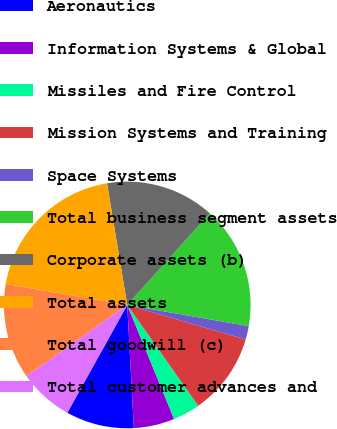<chart> <loc_0><loc_0><loc_500><loc_500><pie_chart><fcel>Aeronautics<fcel>Information Systems & Global<fcel>Missiles and Fire Control<fcel>Mission Systems and Training<fcel>Space Systems<fcel>Total business segment assets<fcel>Corporate assets (b)<fcel>Total assets<fcel>Total goodwill (c)<fcel>Total customer advances and<nl><fcel>8.93%<fcel>5.35%<fcel>3.56%<fcel>10.72%<fcel>1.77%<fcel>16.08%<fcel>14.29%<fcel>19.66%<fcel>12.51%<fcel>7.14%<nl></chart> 